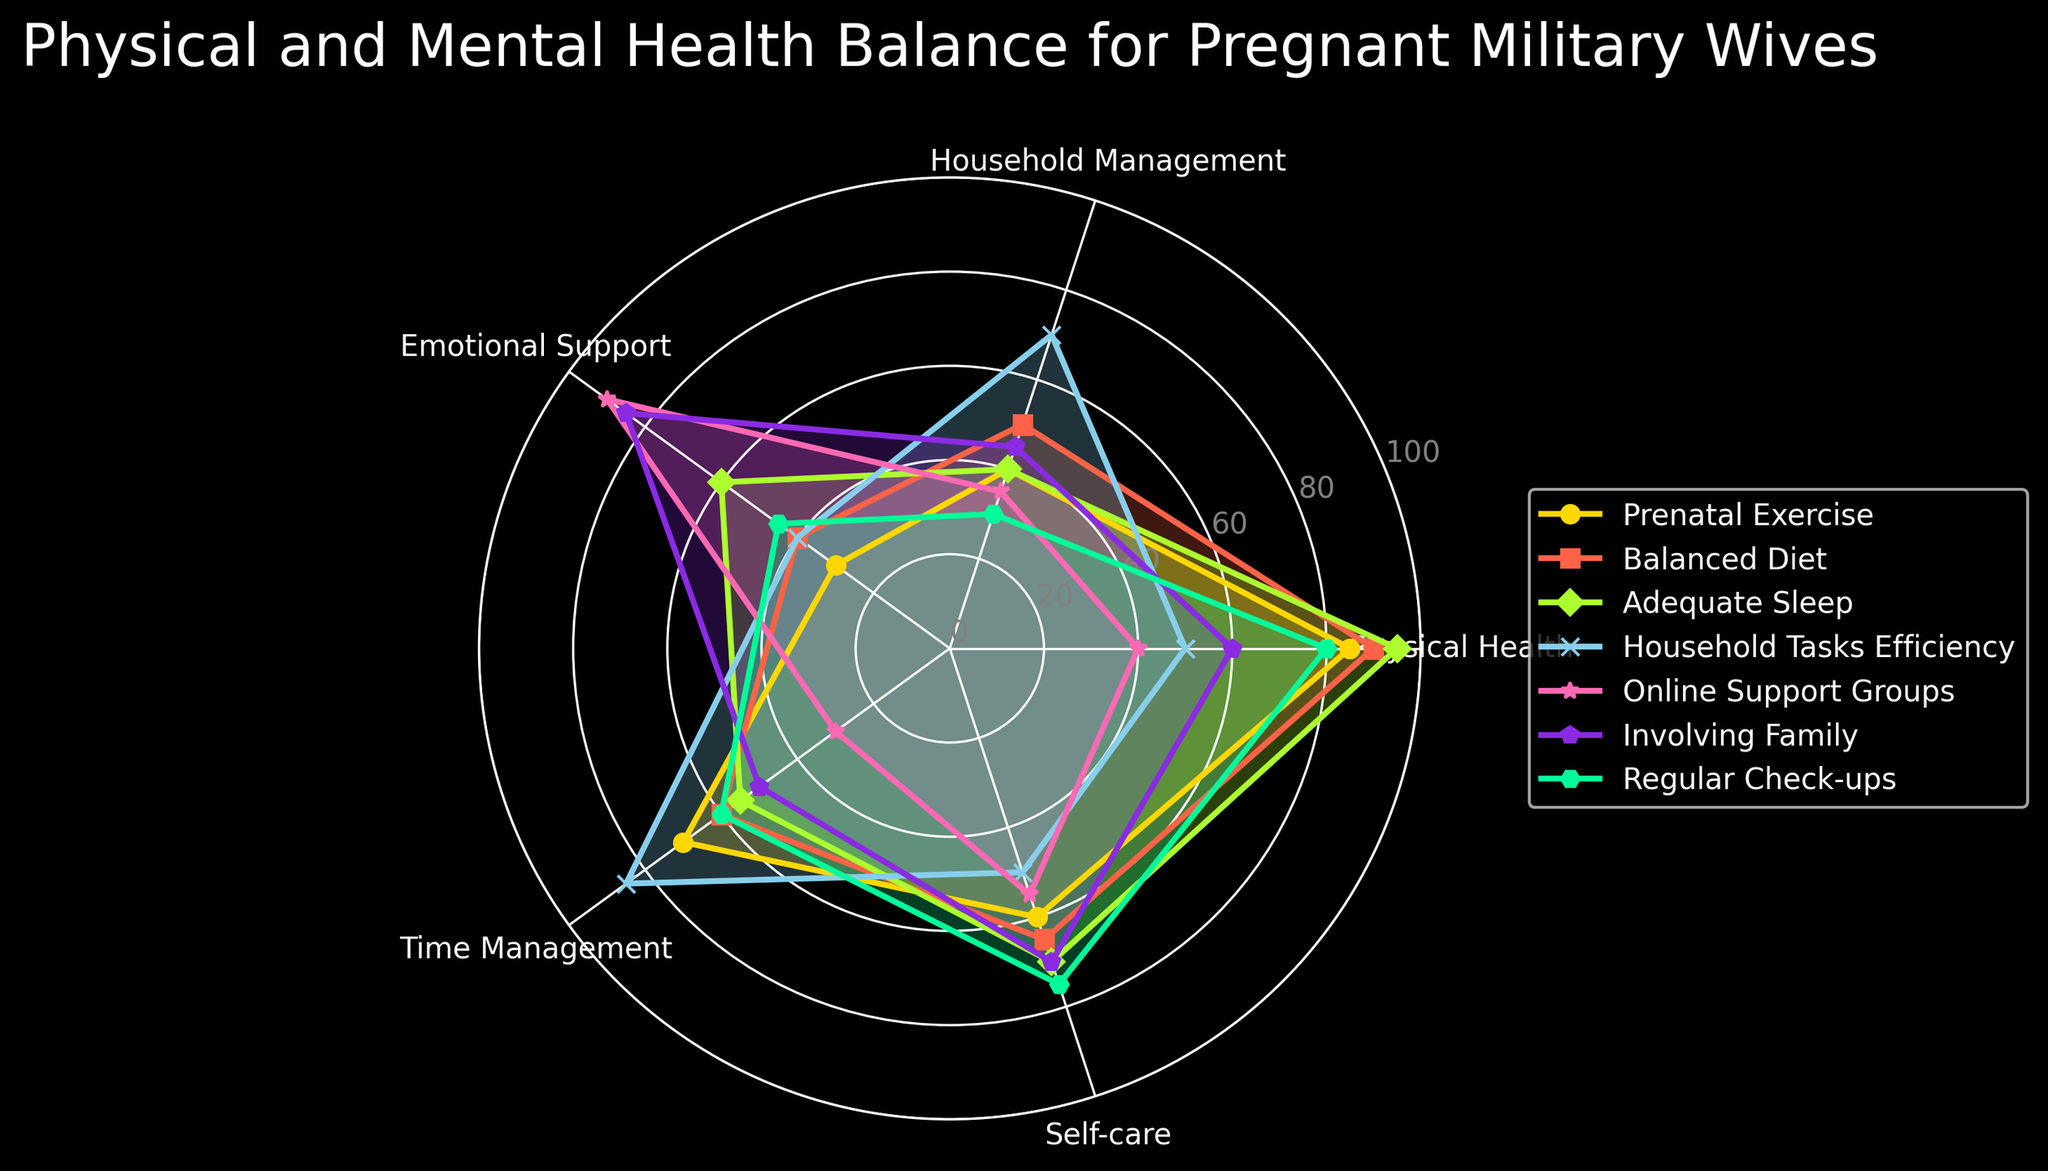What is the highest value in the 'Self-care' category, and which activity does it correspond to? We look at the 'Self-care' values for all activities and find the highest, which is 75, corresponding to 'Regular Check-ups'.
Answer: 75, Regular Check-ups Which category does 'Involving Family' score the highest in? We compare the scores for 'Involving Family' across all categories and find the highest score is 85 in 'Emotional Support'.
Answer: Emotional Support Between 'Prenatal Exercise' and 'Balanced Diet', which has a higher score for 'Time Management', and by how much? 'Prenatal Exercise' has a score of 70 in 'Time Management' while 'Balanced Diet' has a score of 60. The difference is 70 - 60 = 10.
Answer: Prenatal Exercise, 10 For the category 'Physical Health', which activity has the minimum score, and what is that score? 'Online Support Groups' has the lowest 'Physical Health' score with a value of 40.
Answer: Online Support Groups, 40 How does 'Household Tasks Efficiency' compare to 'Adequate Sleep' in 'Household Management'? 'Household Tasks Efficiency' scores 70 in 'Household Management', whereas 'Adequate Sleep' scores 40. Therefore, 'Household Tasks Efficiency' scores 30 more.
Answer: Household Tasks Efficiency, 30 more What is the average score for 'Balanced Diet' across all categories? The scores for 'Balanced Diet' are 90, 50, 40, 60, and 65. The average is (90 + 50 + 40 + 60 + 65) / 5 = 61.
Answer: 61 Which activity shows the greatest variation in scores across all categories? We compute the range (maximum score - minimum score) for each activity. 'Prenatal Exercise' shows the greatest variation with scores ranging from 30 to 85, giving a range of 85 - 30 = 55.
Answer: Prenatal Exercise In the 'Time Management' category, what is the difference between the highest and lowest scores, and which activities do these scores correspond to? The highest score in 'Time Management' is 85 for 'Household Tasks Efficiency', and the lowest is 30 for 'Online Support Groups'. The difference is 85 - 30 = 55.
Answer: 55, Household Tasks Efficiency and Online Support Groups Which activity scores the lowest in the 'Physical Health' category and the highest in the 'Emotional Support' category? 'Online Support Groups' scores the lowest in 'Physical Health' with 40 and the highest in 'Emotional Support' with 90.
Answer: Online Support Groups 